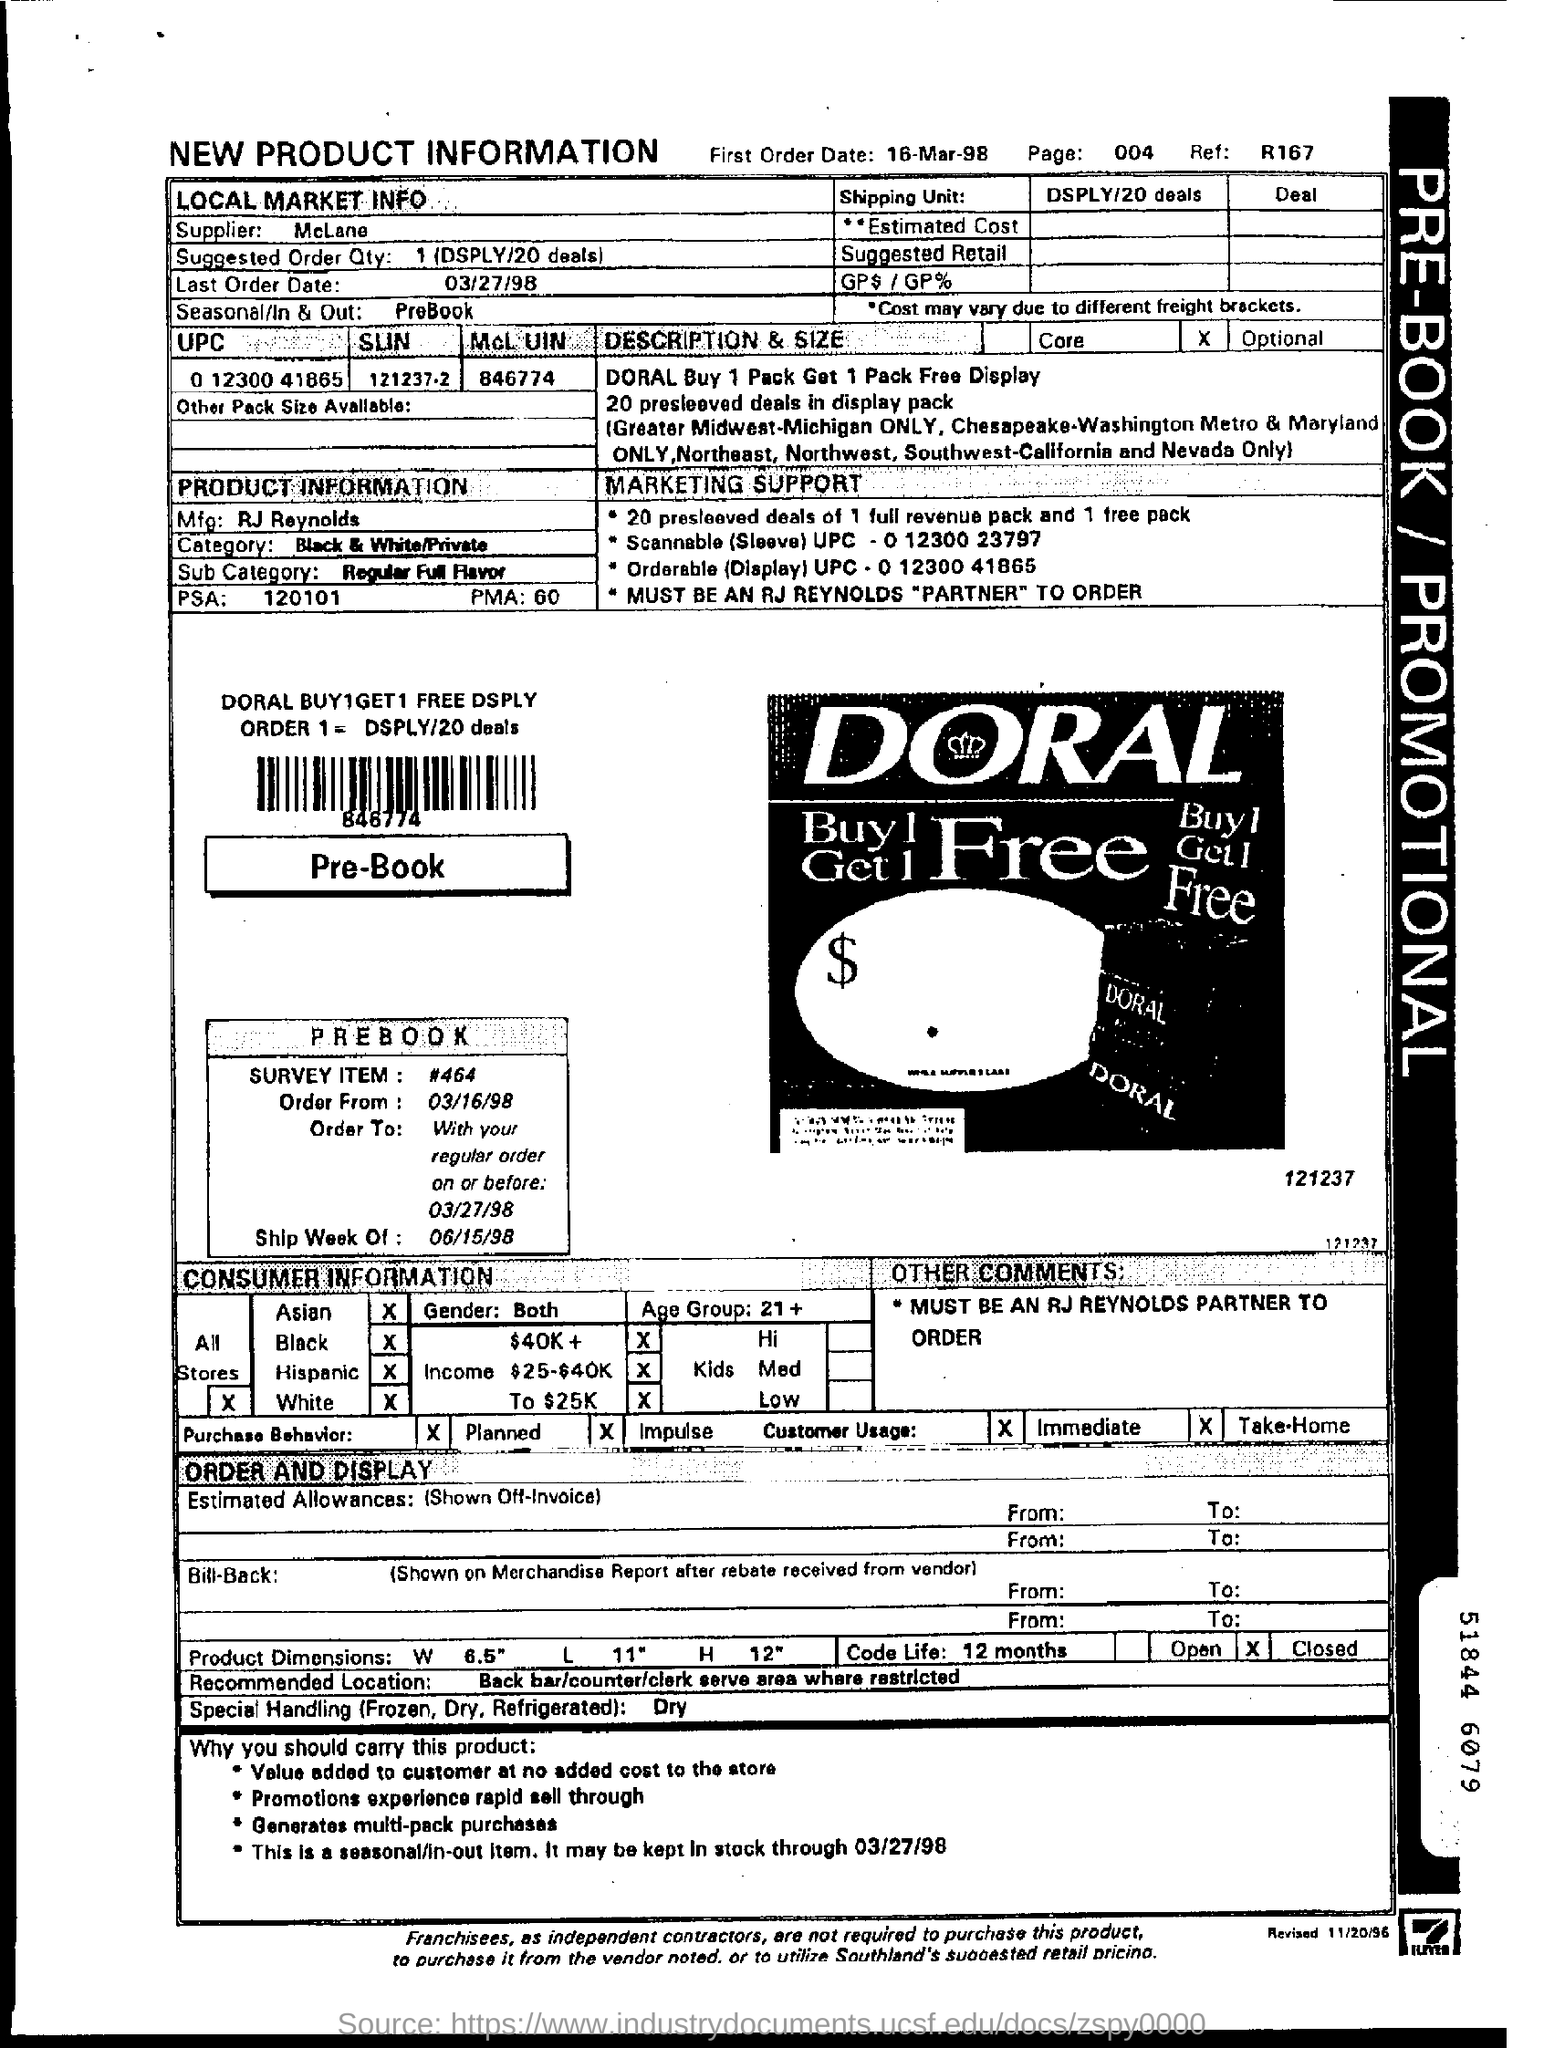List a handful of essential elements in this visual. The first order date is March 16th, 1998. The manufacturer of the product is RJ Reynolds. The last order date was March 27, 1998. What is the recommended order quantity? It ranges from 1 to... 